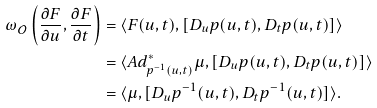Convert formula to latex. <formula><loc_0><loc_0><loc_500><loc_500>\omega _ { \mathcal { O } } \left ( \frac { \partial F } { \partial u } , \frac { \partial F } { \partial t } \right ) & = \langle F ( u , t ) , [ D _ { u } p ( u , t ) , D _ { t } p ( u , t ) ] \rangle \\ & = \langle A d _ { p ^ { - 1 } ( u , t ) } ^ { \ast } \mu , [ D _ { u } p ( u , t ) , D _ { t } p ( u , t ) ] \rangle \\ & = \langle \mu , [ D _ { u } p ^ { - 1 } ( u , t ) , D _ { t } p ^ { - 1 } ( u , t ) ] \rangle .</formula> 